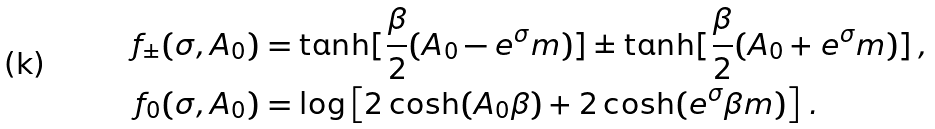<formula> <loc_0><loc_0><loc_500><loc_500>f _ { \pm } ( \sigma , A _ { 0 } ) & = \tanh [ \frac { \beta } { 2 } ( A _ { 0 } - e ^ { \sigma } m ) ] \pm \tanh [ \frac { \beta } { 2 } ( A _ { 0 } + e ^ { \sigma } m ) ] \, , \\ f _ { 0 } ( \sigma , A _ { 0 } ) & = \log \left [ 2 \cosh ( A _ { 0 } \beta ) + 2 \cosh ( e ^ { \sigma } \beta m ) \right ] \, .</formula> 